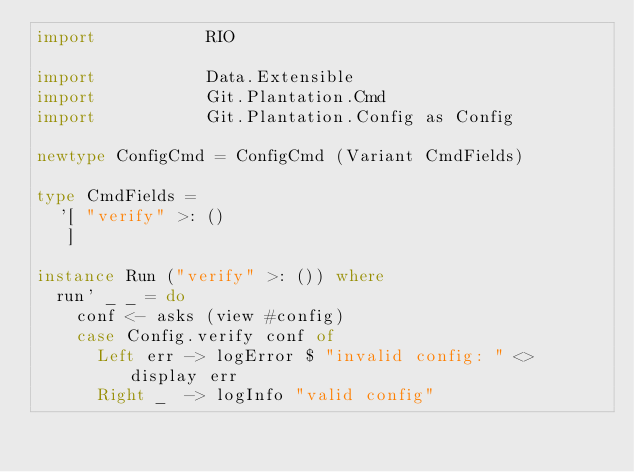<code> <loc_0><loc_0><loc_500><loc_500><_Haskell_>import           RIO

import           Data.Extensible
import           Git.Plantation.Cmd
import           Git.Plantation.Config as Config

newtype ConfigCmd = ConfigCmd (Variant CmdFields)

type CmdFields =
  '[ "verify" >: ()
   ]

instance Run ("verify" >: ()) where
  run' _ _ = do
    conf <- asks (view #config)
    case Config.verify conf of
      Left err -> logError $ "invalid config: " <> display err
      Right _  -> logInfo "valid config"
</code> 